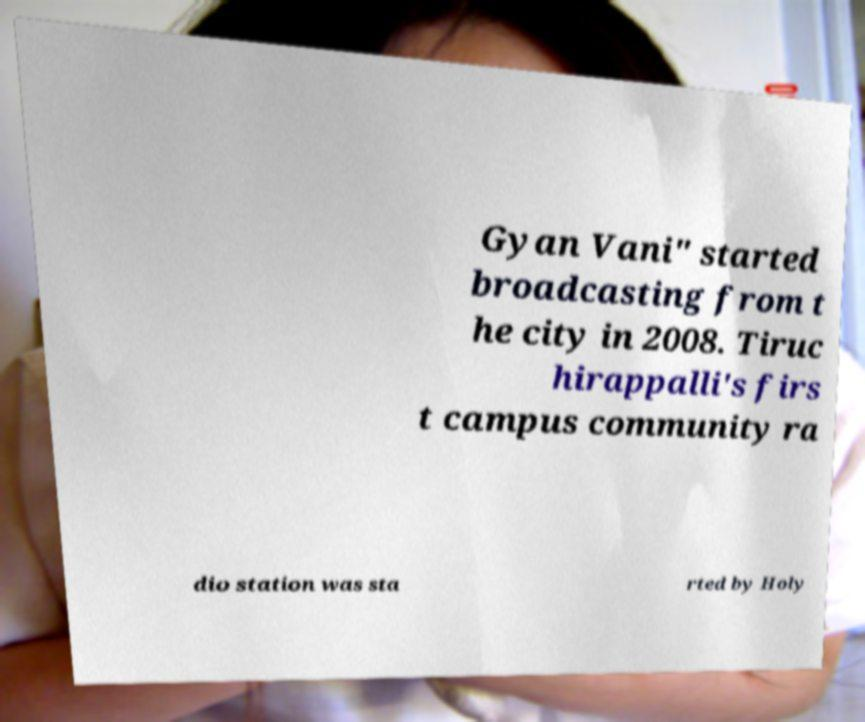There's text embedded in this image that I need extracted. Can you transcribe it verbatim? Gyan Vani" started broadcasting from t he city in 2008. Tiruc hirappalli's firs t campus community ra dio station was sta rted by Holy 